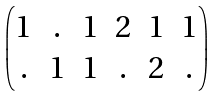<formula> <loc_0><loc_0><loc_500><loc_500>\begin{pmatrix} 1 & . & 1 & 2 & 1 & 1 \\ . & 1 & 1 & . & 2 & . \end{pmatrix}</formula> 